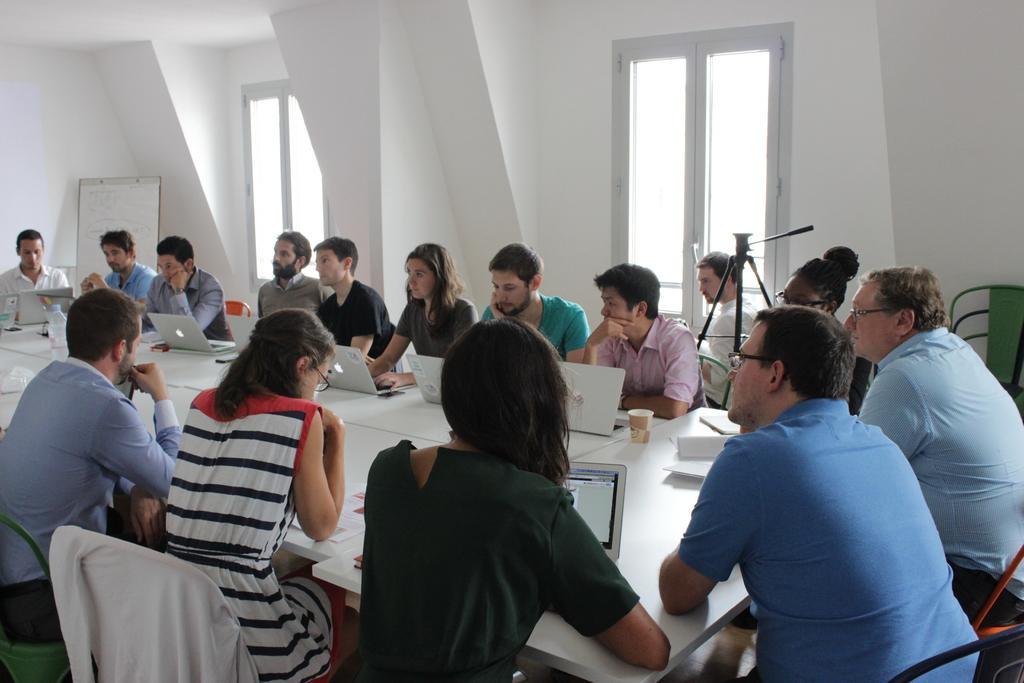Describe this image in one or two sentences. In this image there are few people sitting around a table. There are few laptops on the table. At the left side there is a board behind the person. At the background there are two windows to the wall. 